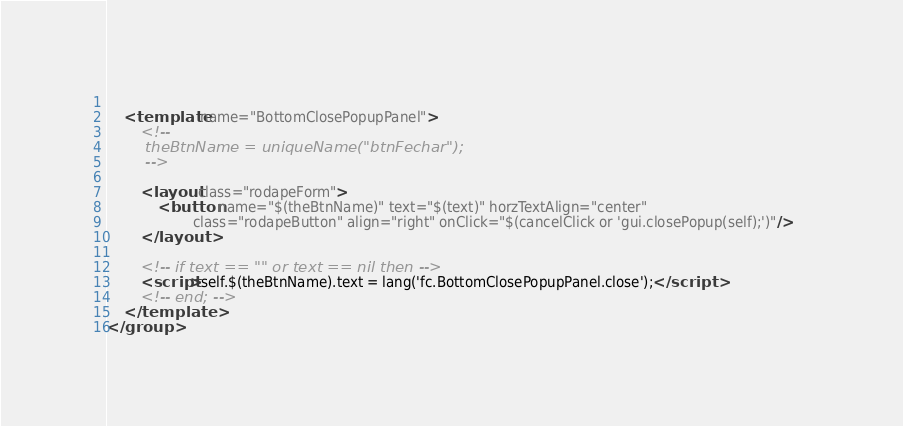Convert code to text. <code><loc_0><loc_0><loc_500><loc_500><_XML_>	
	<template name="BottomClosePopupPanel">
		<!--		
		theBtnName = uniqueName("btnFechar");
		-->
	
		<layout class="rodapeForm">
			<button name="$(theBtnName)" text="$(text)" horzTextAlign="center" 
					class="rodapeButton" align="right" onClick="$(cancelClick or 'gui.closePopup(self);')"/>	
		</layout>		
		
		<!-- if text == "" or text == nil then -->
		<script>self.$(theBtnName).text = lang('fc.BottomClosePopupPanel.close');</script>
		<!-- end; -->
	</template>	
</group></code> 